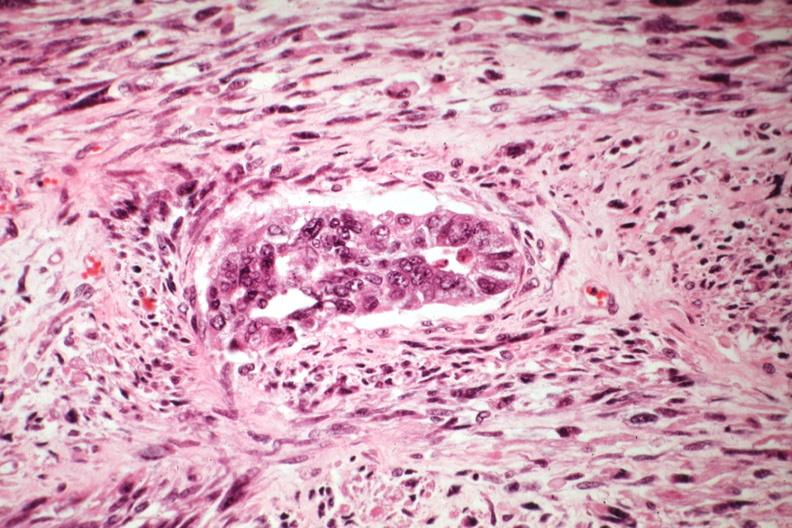does photo show malignant gland and stoma?
Answer the question using a single word or phrase. No 